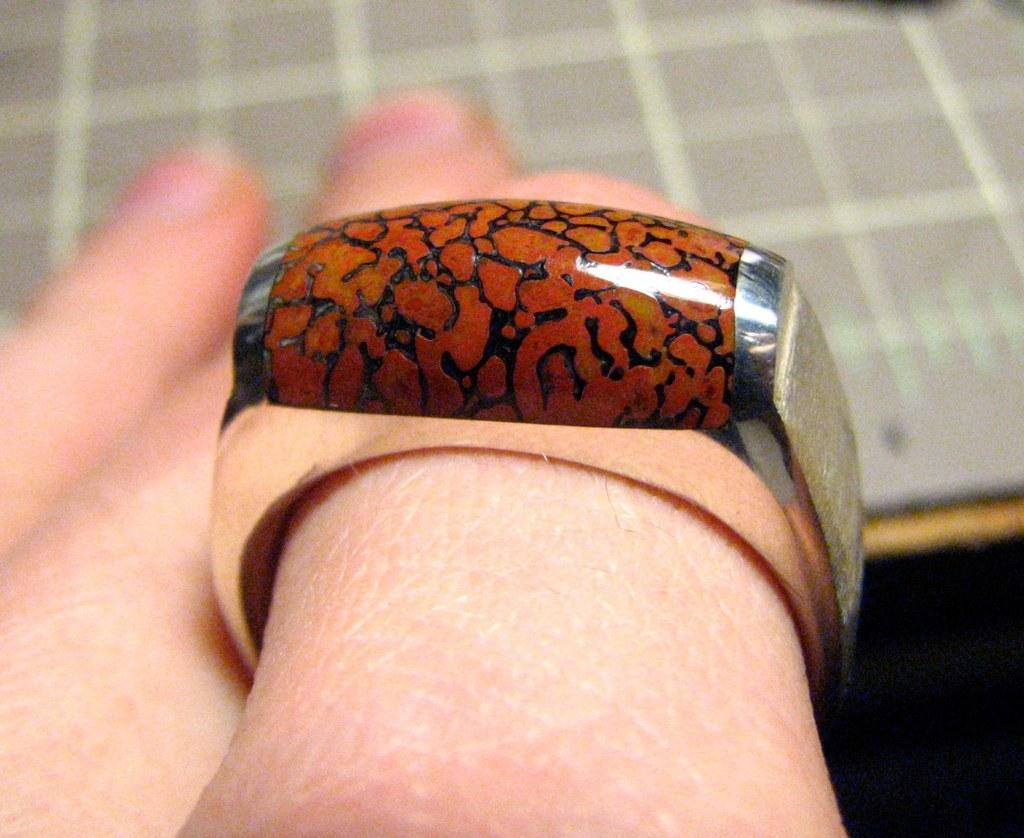What part of a person's body is visible in the image? There is a person's hand in the image. What is on the person's hand? The person's hand has a ring on a finger. Can you describe anything in the background of the image? There is an object in the background of the image. What type of caption is written on the wool in the image? There is no wool or caption present in the image. How many cherries are visible on the person's hand in the image? There are no cherries visible on the person's hand in the image. 